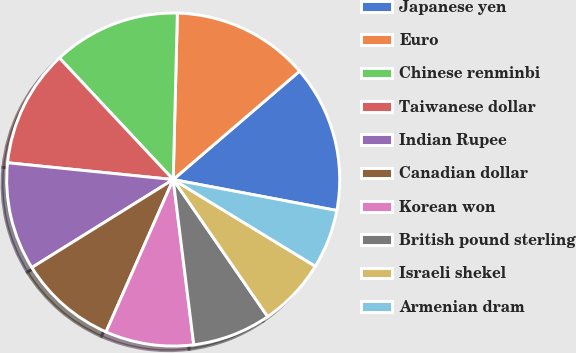Convert chart to OTSL. <chart><loc_0><loc_0><loc_500><loc_500><pie_chart><fcel>Japanese yen<fcel>Euro<fcel>Chinese renminbi<fcel>Taiwanese dollar<fcel>Indian Rupee<fcel>Canadian dollar<fcel>Korean won<fcel>British pound sterling<fcel>Israeli shekel<fcel>Armenian dram<nl><fcel>14.26%<fcel>13.32%<fcel>12.37%<fcel>11.42%<fcel>10.47%<fcel>9.53%<fcel>8.58%<fcel>7.63%<fcel>6.68%<fcel>5.74%<nl></chart> 